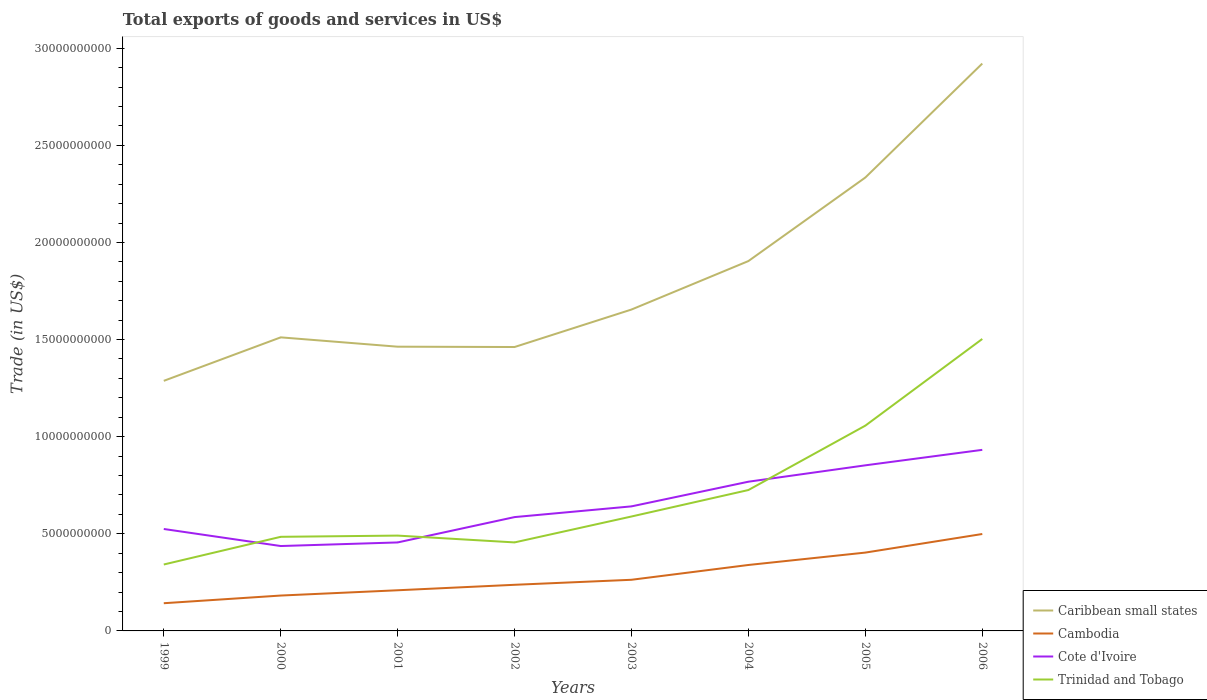How many different coloured lines are there?
Offer a terse response. 4. Across all years, what is the maximum total exports of goods and services in Trinidad and Tobago?
Make the answer very short. 3.42e+09. In which year was the total exports of goods and services in Caribbean small states maximum?
Provide a succinct answer. 1999. What is the total total exports of goods and services in Trinidad and Tobago in the graph?
Give a very brief answer. -1.16e+1. What is the difference between the highest and the second highest total exports of goods and services in Cote d'Ivoire?
Your response must be concise. 4.95e+09. What is the difference between the highest and the lowest total exports of goods and services in Trinidad and Tobago?
Keep it short and to the point. 3. How many lines are there?
Your answer should be very brief. 4. Does the graph contain any zero values?
Make the answer very short. No. Does the graph contain grids?
Ensure brevity in your answer.  No. Where does the legend appear in the graph?
Offer a very short reply. Bottom right. How many legend labels are there?
Provide a short and direct response. 4. What is the title of the graph?
Give a very brief answer. Total exports of goods and services in US$. What is the label or title of the Y-axis?
Your response must be concise. Trade (in US$). What is the Trade (in US$) of Caribbean small states in 1999?
Provide a short and direct response. 1.29e+1. What is the Trade (in US$) in Cambodia in 1999?
Your answer should be very brief. 1.43e+09. What is the Trade (in US$) in Cote d'Ivoire in 1999?
Your answer should be very brief. 5.25e+09. What is the Trade (in US$) of Trinidad and Tobago in 1999?
Your answer should be compact. 3.42e+09. What is the Trade (in US$) of Caribbean small states in 2000?
Your answer should be very brief. 1.51e+1. What is the Trade (in US$) of Cambodia in 2000?
Provide a succinct answer. 1.82e+09. What is the Trade (in US$) of Cote d'Ivoire in 2000?
Provide a short and direct response. 4.37e+09. What is the Trade (in US$) in Trinidad and Tobago in 2000?
Your answer should be very brief. 4.84e+09. What is the Trade (in US$) in Caribbean small states in 2001?
Your answer should be compact. 1.46e+1. What is the Trade (in US$) in Cambodia in 2001?
Keep it short and to the point. 2.09e+09. What is the Trade (in US$) of Cote d'Ivoire in 2001?
Ensure brevity in your answer.  4.56e+09. What is the Trade (in US$) of Trinidad and Tobago in 2001?
Ensure brevity in your answer.  4.91e+09. What is the Trade (in US$) of Caribbean small states in 2002?
Give a very brief answer. 1.46e+1. What is the Trade (in US$) of Cambodia in 2002?
Make the answer very short. 2.37e+09. What is the Trade (in US$) in Cote d'Ivoire in 2002?
Your answer should be compact. 5.86e+09. What is the Trade (in US$) in Trinidad and Tobago in 2002?
Give a very brief answer. 4.56e+09. What is the Trade (in US$) of Caribbean small states in 2003?
Provide a short and direct response. 1.65e+1. What is the Trade (in US$) of Cambodia in 2003?
Your answer should be compact. 2.63e+09. What is the Trade (in US$) in Cote d'Ivoire in 2003?
Make the answer very short. 6.41e+09. What is the Trade (in US$) of Trinidad and Tobago in 2003?
Provide a short and direct response. 5.89e+09. What is the Trade (in US$) of Caribbean small states in 2004?
Your response must be concise. 1.90e+1. What is the Trade (in US$) of Cambodia in 2004?
Your response must be concise. 3.40e+09. What is the Trade (in US$) in Cote d'Ivoire in 2004?
Provide a short and direct response. 7.68e+09. What is the Trade (in US$) in Trinidad and Tobago in 2004?
Your answer should be compact. 7.25e+09. What is the Trade (in US$) of Caribbean small states in 2005?
Provide a short and direct response. 2.33e+1. What is the Trade (in US$) of Cambodia in 2005?
Give a very brief answer. 4.03e+09. What is the Trade (in US$) in Cote d'Ivoire in 2005?
Ensure brevity in your answer.  8.53e+09. What is the Trade (in US$) of Trinidad and Tobago in 2005?
Give a very brief answer. 1.06e+1. What is the Trade (in US$) of Caribbean small states in 2006?
Give a very brief answer. 2.92e+1. What is the Trade (in US$) in Cambodia in 2006?
Provide a succinct answer. 4.99e+09. What is the Trade (in US$) of Cote d'Ivoire in 2006?
Make the answer very short. 9.32e+09. What is the Trade (in US$) of Trinidad and Tobago in 2006?
Provide a succinct answer. 1.50e+1. Across all years, what is the maximum Trade (in US$) in Caribbean small states?
Your response must be concise. 2.92e+1. Across all years, what is the maximum Trade (in US$) of Cambodia?
Your answer should be very brief. 4.99e+09. Across all years, what is the maximum Trade (in US$) of Cote d'Ivoire?
Give a very brief answer. 9.32e+09. Across all years, what is the maximum Trade (in US$) in Trinidad and Tobago?
Keep it short and to the point. 1.50e+1. Across all years, what is the minimum Trade (in US$) in Caribbean small states?
Your answer should be compact. 1.29e+1. Across all years, what is the minimum Trade (in US$) in Cambodia?
Make the answer very short. 1.43e+09. Across all years, what is the minimum Trade (in US$) in Cote d'Ivoire?
Offer a terse response. 4.37e+09. Across all years, what is the minimum Trade (in US$) of Trinidad and Tobago?
Make the answer very short. 3.42e+09. What is the total Trade (in US$) of Caribbean small states in the graph?
Your answer should be very brief. 1.45e+11. What is the total Trade (in US$) of Cambodia in the graph?
Give a very brief answer. 2.28e+1. What is the total Trade (in US$) in Cote d'Ivoire in the graph?
Make the answer very short. 5.20e+1. What is the total Trade (in US$) in Trinidad and Tobago in the graph?
Your answer should be compact. 5.65e+1. What is the difference between the Trade (in US$) of Caribbean small states in 1999 and that in 2000?
Provide a succinct answer. -2.24e+09. What is the difference between the Trade (in US$) of Cambodia in 1999 and that in 2000?
Provide a succinct answer. -3.95e+08. What is the difference between the Trade (in US$) of Cote d'Ivoire in 1999 and that in 2000?
Your response must be concise. 8.77e+08. What is the difference between the Trade (in US$) of Trinidad and Tobago in 1999 and that in 2000?
Provide a short and direct response. -1.43e+09. What is the difference between the Trade (in US$) of Caribbean small states in 1999 and that in 2001?
Offer a terse response. -1.76e+09. What is the difference between the Trade (in US$) of Cambodia in 1999 and that in 2001?
Your answer should be very brief. -6.67e+08. What is the difference between the Trade (in US$) of Cote d'Ivoire in 1999 and that in 2001?
Give a very brief answer. 6.93e+08. What is the difference between the Trade (in US$) of Trinidad and Tobago in 1999 and that in 2001?
Give a very brief answer. -1.49e+09. What is the difference between the Trade (in US$) of Caribbean small states in 1999 and that in 2002?
Keep it short and to the point. -1.74e+09. What is the difference between the Trade (in US$) of Cambodia in 1999 and that in 2002?
Offer a terse response. -9.48e+08. What is the difference between the Trade (in US$) in Cote d'Ivoire in 1999 and that in 2002?
Give a very brief answer. -6.12e+08. What is the difference between the Trade (in US$) of Trinidad and Tobago in 1999 and that in 2002?
Provide a short and direct response. -1.14e+09. What is the difference between the Trade (in US$) of Caribbean small states in 1999 and that in 2003?
Provide a succinct answer. -3.67e+09. What is the difference between the Trade (in US$) in Cambodia in 1999 and that in 2003?
Your response must be concise. -1.21e+09. What is the difference between the Trade (in US$) of Cote d'Ivoire in 1999 and that in 2003?
Your response must be concise. -1.16e+09. What is the difference between the Trade (in US$) of Trinidad and Tobago in 1999 and that in 2003?
Provide a short and direct response. -2.47e+09. What is the difference between the Trade (in US$) of Caribbean small states in 1999 and that in 2004?
Offer a very short reply. -6.17e+09. What is the difference between the Trade (in US$) in Cambodia in 1999 and that in 2004?
Offer a very short reply. -1.97e+09. What is the difference between the Trade (in US$) of Cote d'Ivoire in 1999 and that in 2004?
Offer a very short reply. -2.43e+09. What is the difference between the Trade (in US$) of Trinidad and Tobago in 1999 and that in 2004?
Keep it short and to the point. -3.83e+09. What is the difference between the Trade (in US$) of Caribbean small states in 1999 and that in 2005?
Offer a very short reply. -1.05e+1. What is the difference between the Trade (in US$) in Cambodia in 1999 and that in 2005?
Make the answer very short. -2.61e+09. What is the difference between the Trade (in US$) in Cote d'Ivoire in 1999 and that in 2005?
Ensure brevity in your answer.  -3.28e+09. What is the difference between the Trade (in US$) of Trinidad and Tobago in 1999 and that in 2005?
Your response must be concise. -7.15e+09. What is the difference between the Trade (in US$) of Caribbean small states in 1999 and that in 2006?
Ensure brevity in your answer.  -1.63e+1. What is the difference between the Trade (in US$) of Cambodia in 1999 and that in 2006?
Offer a very short reply. -3.56e+09. What is the difference between the Trade (in US$) of Cote d'Ivoire in 1999 and that in 2006?
Keep it short and to the point. -4.07e+09. What is the difference between the Trade (in US$) in Trinidad and Tobago in 1999 and that in 2006?
Provide a short and direct response. -1.16e+1. What is the difference between the Trade (in US$) of Caribbean small states in 2000 and that in 2001?
Give a very brief answer. 4.81e+08. What is the difference between the Trade (in US$) in Cambodia in 2000 and that in 2001?
Your answer should be very brief. -2.72e+08. What is the difference between the Trade (in US$) of Cote d'Ivoire in 2000 and that in 2001?
Keep it short and to the point. -1.85e+08. What is the difference between the Trade (in US$) of Trinidad and Tobago in 2000 and that in 2001?
Offer a terse response. -6.28e+07. What is the difference between the Trade (in US$) in Caribbean small states in 2000 and that in 2002?
Offer a very short reply. 4.97e+08. What is the difference between the Trade (in US$) in Cambodia in 2000 and that in 2002?
Provide a short and direct response. -5.53e+08. What is the difference between the Trade (in US$) in Cote d'Ivoire in 2000 and that in 2002?
Ensure brevity in your answer.  -1.49e+09. What is the difference between the Trade (in US$) of Trinidad and Tobago in 2000 and that in 2002?
Offer a very short reply. 2.88e+08. What is the difference between the Trade (in US$) in Caribbean small states in 2000 and that in 2003?
Your answer should be compact. -1.43e+09. What is the difference between the Trade (in US$) in Cambodia in 2000 and that in 2003?
Ensure brevity in your answer.  -8.11e+08. What is the difference between the Trade (in US$) of Cote d'Ivoire in 2000 and that in 2003?
Offer a very short reply. -2.04e+09. What is the difference between the Trade (in US$) of Trinidad and Tobago in 2000 and that in 2003?
Give a very brief answer. -1.05e+09. What is the difference between the Trade (in US$) in Caribbean small states in 2000 and that in 2004?
Your answer should be compact. -3.93e+09. What is the difference between the Trade (in US$) of Cambodia in 2000 and that in 2004?
Your response must be concise. -1.57e+09. What is the difference between the Trade (in US$) of Cote d'Ivoire in 2000 and that in 2004?
Provide a succinct answer. -3.31e+09. What is the difference between the Trade (in US$) of Trinidad and Tobago in 2000 and that in 2004?
Offer a very short reply. -2.41e+09. What is the difference between the Trade (in US$) in Caribbean small states in 2000 and that in 2005?
Make the answer very short. -8.23e+09. What is the difference between the Trade (in US$) in Cambodia in 2000 and that in 2005?
Your response must be concise. -2.21e+09. What is the difference between the Trade (in US$) in Cote d'Ivoire in 2000 and that in 2005?
Provide a succinct answer. -4.15e+09. What is the difference between the Trade (in US$) of Trinidad and Tobago in 2000 and that in 2005?
Your answer should be compact. -5.72e+09. What is the difference between the Trade (in US$) of Caribbean small states in 2000 and that in 2006?
Keep it short and to the point. -1.41e+1. What is the difference between the Trade (in US$) in Cambodia in 2000 and that in 2006?
Keep it short and to the point. -3.17e+09. What is the difference between the Trade (in US$) in Cote d'Ivoire in 2000 and that in 2006?
Provide a succinct answer. -4.95e+09. What is the difference between the Trade (in US$) of Trinidad and Tobago in 2000 and that in 2006?
Offer a very short reply. -1.02e+1. What is the difference between the Trade (in US$) of Caribbean small states in 2001 and that in 2002?
Keep it short and to the point. 1.66e+07. What is the difference between the Trade (in US$) of Cambodia in 2001 and that in 2002?
Provide a succinct answer. -2.81e+08. What is the difference between the Trade (in US$) in Cote d'Ivoire in 2001 and that in 2002?
Your response must be concise. -1.30e+09. What is the difference between the Trade (in US$) in Trinidad and Tobago in 2001 and that in 2002?
Make the answer very short. 3.51e+08. What is the difference between the Trade (in US$) in Caribbean small states in 2001 and that in 2003?
Offer a terse response. -1.91e+09. What is the difference between the Trade (in US$) of Cambodia in 2001 and that in 2003?
Offer a very short reply. -5.40e+08. What is the difference between the Trade (in US$) in Cote d'Ivoire in 2001 and that in 2003?
Keep it short and to the point. -1.86e+09. What is the difference between the Trade (in US$) in Trinidad and Tobago in 2001 and that in 2003?
Give a very brief answer. -9.84e+08. What is the difference between the Trade (in US$) in Caribbean small states in 2001 and that in 2004?
Make the answer very short. -4.41e+09. What is the difference between the Trade (in US$) in Cambodia in 2001 and that in 2004?
Your response must be concise. -1.30e+09. What is the difference between the Trade (in US$) of Cote d'Ivoire in 2001 and that in 2004?
Your answer should be compact. -3.13e+09. What is the difference between the Trade (in US$) in Trinidad and Tobago in 2001 and that in 2004?
Provide a short and direct response. -2.35e+09. What is the difference between the Trade (in US$) in Caribbean small states in 2001 and that in 2005?
Your answer should be very brief. -8.71e+09. What is the difference between the Trade (in US$) in Cambodia in 2001 and that in 2005?
Ensure brevity in your answer.  -1.94e+09. What is the difference between the Trade (in US$) of Cote d'Ivoire in 2001 and that in 2005?
Your response must be concise. -3.97e+09. What is the difference between the Trade (in US$) of Trinidad and Tobago in 2001 and that in 2005?
Offer a terse response. -5.66e+09. What is the difference between the Trade (in US$) of Caribbean small states in 2001 and that in 2006?
Provide a succinct answer. -1.46e+1. What is the difference between the Trade (in US$) of Cambodia in 2001 and that in 2006?
Provide a short and direct response. -2.90e+09. What is the difference between the Trade (in US$) in Cote d'Ivoire in 2001 and that in 2006?
Offer a very short reply. -4.77e+09. What is the difference between the Trade (in US$) of Trinidad and Tobago in 2001 and that in 2006?
Offer a very short reply. -1.01e+1. What is the difference between the Trade (in US$) in Caribbean small states in 2002 and that in 2003?
Ensure brevity in your answer.  -1.93e+09. What is the difference between the Trade (in US$) in Cambodia in 2002 and that in 2003?
Your answer should be compact. -2.59e+08. What is the difference between the Trade (in US$) in Cote d'Ivoire in 2002 and that in 2003?
Your response must be concise. -5.52e+08. What is the difference between the Trade (in US$) in Trinidad and Tobago in 2002 and that in 2003?
Keep it short and to the point. -1.33e+09. What is the difference between the Trade (in US$) in Caribbean small states in 2002 and that in 2004?
Provide a short and direct response. -4.43e+09. What is the difference between the Trade (in US$) in Cambodia in 2002 and that in 2004?
Make the answer very short. -1.02e+09. What is the difference between the Trade (in US$) of Cote d'Ivoire in 2002 and that in 2004?
Provide a short and direct response. -1.82e+09. What is the difference between the Trade (in US$) of Trinidad and Tobago in 2002 and that in 2004?
Your answer should be very brief. -2.70e+09. What is the difference between the Trade (in US$) in Caribbean small states in 2002 and that in 2005?
Keep it short and to the point. -8.73e+09. What is the difference between the Trade (in US$) in Cambodia in 2002 and that in 2005?
Ensure brevity in your answer.  -1.66e+09. What is the difference between the Trade (in US$) of Cote d'Ivoire in 2002 and that in 2005?
Ensure brevity in your answer.  -2.66e+09. What is the difference between the Trade (in US$) in Trinidad and Tobago in 2002 and that in 2005?
Keep it short and to the point. -6.01e+09. What is the difference between the Trade (in US$) of Caribbean small states in 2002 and that in 2006?
Ensure brevity in your answer.  -1.46e+1. What is the difference between the Trade (in US$) of Cambodia in 2002 and that in 2006?
Provide a short and direct response. -2.62e+09. What is the difference between the Trade (in US$) of Cote d'Ivoire in 2002 and that in 2006?
Your answer should be very brief. -3.46e+09. What is the difference between the Trade (in US$) in Trinidad and Tobago in 2002 and that in 2006?
Ensure brevity in your answer.  -1.05e+1. What is the difference between the Trade (in US$) in Caribbean small states in 2003 and that in 2004?
Offer a very short reply. -2.50e+09. What is the difference between the Trade (in US$) in Cambodia in 2003 and that in 2004?
Offer a terse response. -7.62e+08. What is the difference between the Trade (in US$) of Cote d'Ivoire in 2003 and that in 2004?
Give a very brief answer. -1.27e+09. What is the difference between the Trade (in US$) of Trinidad and Tobago in 2003 and that in 2004?
Offer a terse response. -1.36e+09. What is the difference between the Trade (in US$) in Caribbean small states in 2003 and that in 2005?
Provide a succinct answer. -6.80e+09. What is the difference between the Trade (in US$) of Cambodia in 2003 and that in 2005?
Give a very brief answer. -1.40e+09. What is the difference between the Trade (in US$) in Cote d'Ivoire in 2003 and that in 2005?
Keep it short and to the point. -2.11e+09. What is the difference between the Trade (in US$) in Trinidad and Tobago in 2003 and that in 2005?
Make the answer very short. -4.68e+09. What is the difference between the Trade (in US$) in Caribbean small states in 2003 and that in 2006?
Your response must be concise. -1.27e+1. What is the difference between the Trade (in US$) in Cambodia in 2003 and that in 2006?
Provide a short and direct response. -2.36e+09. What is the difference between the Trade (in US$) in Cote d'Ivoire in 2003 and that in 2006?
Keep it short and to the point. -2.91e+09. What is the difference between the Trade (in US$) in Trinidad and Tobago in 2003 and that in 2006?
Give a very brief answer. -9.14e+09. What is the difference between the Trade (in US$) in Caribbean small states in 2004 and that in 2005?
Your answer should be very brief. -4.30e+09. What is the difference between the Trade (in US$) in Cambodia in 2004 and that in 2005?
Your response must be concise. -6.38e+08. What is the difference between the Trade (in US$) in Cote d'Ivoire in 2004 and that in 2005?
Offer a terse response. -8.43e+08. What is the difference between the Trade (in US$) in Trinidad and Tobago in 2004 and that in 2005?
Offer a terse response. -3.31e+09. What is the difference between the Trade (in US$) in Caribbean small states in 2004 and that in 2006?
Provide a succinct answer. -1.02e+1. What is the difference between the Trade (in US$) in Cambodia in 2004 and that in 2006?
Your answer should be compact. -1.59e+09. What is the difference between the Trade (in US$) in Cote d'Ivoire in 2004 and that in 2006?
Provide a short and direct response. -1.64e+09. What is the difference between the Trade (in US$) in Trinidad and Tobago in 2004 and that in 2006?
Your answer should be very brief. -7.78e+09. What is the difference between the Trade (in US$) of Caribbean small states in 2005 and that in 2006?
Keep it short and to the point. -5.87e+09. What is the difference between the Trade (in US$) of Cambodia in 2005 and that in 2006?
Your response must be concise. -9.57e+08. What is the difference between the Trade (in US$) of Cote d'Ivoire in 2005 and that in 2006?
Provide a short and direct response. -7.97e+08. What is the difference between the Trade (in US$) in Trinidad and Tobago in 2005 and that in 2006?
Offer a very short reply. -4.46e+09. What is the difference between the Trade (in US$) in Caribbean small states in 1999 and the Trade (in US$) in Cambodia in 2000?
Offer a very short reply. 1.11e+1. What is the difference between the Trade (in US$) of Caribbean small states in 1999 and the Trade (in US$) of Cote d'Ivoire in 2000?
Make the answer very short. 8.50e+09. What is the difference between the Trade (in US$) of Caribbean small states in 1999 and the Trade (in US$) of Trinidad and Tobago in 2000?
Offer a very short reply. 8.03e+09. What is the difference between the Trade (in US$) in Cambodia in 1999 and the Trade (in US$) in Cote d'Ivoire in 2000?
Make the answer very short. -2.94e+09. What is the difference between the Trade (in US$) in Cambodia in 1999 and the Trade (in US$) in Trinidad and Tobago in 2000?
Your answer should be very brief. -3.42e+09. What is the difference between the Trade (in US$) of Cote d'Ivoire in 1999 and the Trade (in US$) of Trinidad and Tobago in 2000?
Offer a terse response. 4.03e+08. What is the difference between the Trade (in US$) of Caribbean small states in 1999 and the Trade (in US$) of Cambodia in 2001?
Ensure brevity in your answer.  1.08e+1. What is the difference between the Trade (in US$) of Caribbean small states in 1999 and the Trade (in US$) of Cote d'Ivoire in 2001?
Offer a very short reply. 8.32e+09. What is the difference between the Trade (in US$) of Caribbean small states in 1999 and the Trade (in US$) of Trinidad and Tobago in 2001?
Ensure brevity in your answer.  7.97e+09. What is the difference between the Trade (in US$) in Cambodia in 1999 and the Trade (in US$) in Cote d'Ivoire in 2001?
Your answer should be compact. -3.13e+09. What is the difference between the Trade (in US$) in Cambodia in 1999 and the Trade (in US$) in Trinidad and Tobago in 2001?
Make the answer very short. -3.48e+09. What is the difference between the Trade (in US$) in Cote d'Ivoire in 1999 and the Trade (in US$) in Trinidad and Tobago in 2001?
Offer a terse response. 3.40e+08. What is the difference between the Trade (in US$) of Caribbean small states in 1999 and the Trade (in US$) of Cambodia in 2002?
Your answer should be compact. 1.05e+1. What is the difference between the Trade (in US$) of Caribbean small states in 1999 and the Trade (in US$) of Cote d'Ivoire in 2002?
Offer a terse response. 7.01e+09. What is the difference between the Trade (in US$) of Caribbean small states in 1999 and the Trade (in US$) of Trinidad and Tobago in 2002?
Your answer should be compact. 8.32e+09. What is the difference between the Trade (in US$) in Cambodia in 1999 and the Trade (in US$) in Cote d'Ivoire in 2002?
Your response must be concise. -4.43e+09. What is the difference between the Trade (in US$) of Cambodia in 1999 and the Trade (in US$) of Trinidad and Tobago in 2002?
Give a very brief answer. -3.13e+09. What is the difference between the Trade (in US$) in Cote d'Ivoire in 1999 and the Trade (in US$) in Trinidad and Tobago in 2002?
Give a very brief answer. 6.91e+08. What is the difference between the Trade (in US$) of Caribbean small states in 1999 and the Trade (in US$) of Cambodia in 2003?
Offer a terse response. 1.02e+1. What is the difference between the Trade (in US$) of Caribbean small states in 1999 and the Trade (in US$) of Cote d'Ivoire in 2003?
Make the answer very short. 6.46e+09. What is the difference between the Trade (in US$) of Caribbean small states in 1999 and the Trade (in US$) of Trinidad and Tobago in 2003?
Offer a very short reply. 6.98e+09. What is the difference between the Trade (in US$) of Cambodia in 1999 and the Trade (in US$) of Cote d'Ivoire in 2003?
Provide a succinct answer. -4.99e+09. What is the difference between the Trade (in US$) of Cambodia in 1999 and the Trade (in US$) of Trinidad and Tobago in 2003?
Make the answer very short. -4.47e+09. What is the difference between the Trade (in US$) of Cote d'Ivoire in 1999 and the Trade (in US$) of Trinidad and Tobago in 2003?
Your response must be concise. -6.43e+08. What is the difference between the Trade (in US$) in Caribbean small states in 1999 and the Trade (in US$) in Cambodia in 2004?
Ensure brevity in your answer.  9.48e+09. What is the difference between the Trade (in US$) in Caribbean small states in 1999 and the Trade (in US$) in Cote d'Ivoire in 2004?
Ensure brevity in your answer.  5.19e+09. What is the difference between the Trade (in US$) of Caribbean small states in 1999 and the Trade (in US$) of Trinidad and Tobago in 2004?
Give a very brief answer. 5.62e+09. What is the difference between the Trade (in US$) of Cambodia in 1999 and the Trade (in US$) of Cote d'Ivoire in 2004?
Provide a short and direct response. -6.26e+09. What is the difference between the Trade (in US$) in Cambodia in 1999 and the Trade (in US$) in Trinidad and Tobago in 2004?
Provide a short and direct response. -5.83e+09. What is the difference between the Trade (in US$) of Cote d'Ivoire in 1999 and the Trade (in US$) of Trinidad and Tobago in 2004?
Give a very brief answer. -2.01e+09. What is the difference between the Trade (in US$) in Caribbean small states in 1999 and the Trade (in US$) in Cambodia in 2005?
Keep it short and to the point. 8.84e+09. What is the difference between the Trade (in US$) of Caribbean small states in 1999 and the Trade (in US$) of Cote d'Ivoire in 2005?
Make the answer very short. 4.35e+09. What is the difference between the Trade (in US$) in Caribbean small states in 1999 and the Trade (in US$) in Trinidad and Tobago in 2005?
Give a very brief answer. 2.31e+09. What is the difference between the Trade (in US$) of Cambodia in 1999 and the Trade (in US$) of Cote d'Ivoire in 2005?
Make the answer very short. -7.10e+09. What is the difference between the Trade (in US$) in Cambodia in 1999 and the Trade (in US$) in Trinidad and Tobago in 2005?
Make the answer very short. -9.14e+09. What is the difference between the Trade (in US$) in Cote d'Ivoire in 1999 and the Trade (in US$) in Trinidad and Tobago in 2005?
Make the answer very short. -5.32e+09. What is the difference between the Trade (in US$) in Caribbean small states in 1999 and the Trade (in US$) in Cambodia in 2006?
Make the answer very short. 7.88e+09. What is the difference between the Trade (in US$) of Caribbean small states in 1999 and the Trade (in US$) of Cote d'Ivoire in 2006?
Offer a very short reply. 3.55e+09. What is the difference between the Trade (in US$) in Caribbean small states in 1999 and the Trade (in US$) in Trinidad and Tobago in 2006?
Provide a short and direct response. -2.16e+09. What is the difference between the Trade (in US$) in Cambodia in 1999 and the Trade (in US$) in Cote d'Ivoire in 2006?
Provide a succinct answer. -7.90e+09. What is the difference between the Trade (in US$) of Cambodia in 1999 and the Trade (in US$) of Trinidad and Tobago in 2006?
Make the answer very short. -1.36e+1. What is the difference between the Trade (in US$) of Cote d'Ivoire in 1999 and the Trade (in US$) of Trinidad and Tobago in 2006?
Your answer should be compact. -9.78e+09. What is the difference between the Trade (in US$) of Caribbean small states in 2000 and the Trade (in US$) of Cambodia in 2001?
Make the answer very short. 1.30e+1. What is the difference between the Trade (in US$) of Caribbean small states in 2000 and the Trade (in US$) of Cote d'Ivoire in 2001?
Offer a terse response. 1.06e+1. What is the difference between the Trade (in US$) in Caribbean small states in 2000 and the Trade (in US$) in Trinidad and Tobago in 2001?
Keep it short and to the point. 1.02e+1. What is the difference between the Trade (in US$) in Cambodia in 2000 and the Trade (in US$) in Cote d'Ivoire in 2001?
Make the answer very short. -2.73e+09. What is the difference between the Trade (in US$) of Cambodia in 2000 and the Trade (in US$) of Trinidad and Tobago in 2001?
Your answer should be compact. -3.09e+09. What is the difference between the Trade (in US$) of Cote d'Ivoire in 2000 and the Trade (in US$) of Trinidad and Tobago in 2001?
Make the answer very short. -5.37e+08. What is the difference between the Trade (in US$) in Caribbean small states in 2000 and the Trade (in US$) in Cambodia in 2002?
Offer a terse response. 1.27e+1. What is the difference between the Trade (in US$) in Caribbean small states in 2000 and the Trade (in US$) in Cote d'Ivoire in 2002?
Provide a short and direct response. 9.25e+09. What is the difference between the Trade (in US$) in Caribbean small states in 2000 and the Trade (in US$) in Trinidad and Tobago in 2002?
Keep it short and to the point. 1.06e+1. What is the difference between the Trade (in US$) of Cambodia in 2000 and the Trade (in US$) of Cote d'Ivoire in 2002?
Provide a succinct answer. -4.04e+09. What is the difference between the Trade (in US$) in Cambodia in 2000 and the Trade (in US$) in Trinidad and Tobago in 2002?
Offer a very short reply. -2.74e+09. What is the difference between the Trade (in US$) of Cote d'Ivoire in 2000 and the Trade (in US$) of Trinidad and Tobago in 2002?
Offer a terse response. -1.86e+08. What is the difference between the Trade (in US$) of Caribbean small states in 2000 and the Trade (in US$) of Cambodia in 2003?
Make the answer very short. 1.25e+1. What is the difference between the Trade (in US$) in Caribbean small states in 2000 and the Trade (in US$) in Cote d'Ivoire in 2003?
Offer a very short reply. 8.70e+09. What is the difference between the Trade (in US$) of Caribbean small states in 2000 and the Trade (in US$) of Trinidad and Tobago in 2003?
Offer a terse response. 9.22e+09. What is the difference between the Trade (in US$) in Cambodia in 2000 and the Trade (in US$) in Cote d'Ivoire in 2003?
Give a very brief answer. -4.59e+09. What is the difference between the Trade (in US$) of Cambodia in 2000 and the Trade (in US$) of Trinidad and Tobago in 2003?
Ensure brevity in your answer.  -4.07e+09. What is the difference between the Trade (in US$) in Cote d'Ivoire in 2000 and the Trade (in US$) in Trinidad and Tobago in 2003?
Make the answer very short. -1.52e+09. What is the difference between the Trade (in US$) of Caribbean small states in 2000 and the Trade (in US$) of Cambodia in 2004?
Your answer should be very brief. 1.17e+1. What is the difference between the Trade (in US$) of Caribbean small states in 2000 and the Trade (in US$) of Cote d'Ivoire in 2004?
Your answer should be compact. 7.43e+09. What is the difference between the Trade (in US$) of Caribbean small states in 2000 and the Trade (in US$) of Trinidad and Tobago in 2004?
Give a very brief answer. 7.86e+09. What is the difference between the Trade (in US$) in Cambodia in 2000 and the Trade (in US$) in Cote d'Ivoire in 2004?
Your response must be concise. -5.86e+09. What is the difference between the Trade (in US$) of Cambodia in 2000 and the Trade (in US$) of Trinidad and Tobago in 2004?
Offer a very short reply. -5.43e+09. What is the difference between the Trade (in US$) of Cote d'Ivoire in 2000 and the Trade (in US$) of Trinidad and Tobago in 2004?
Your response must be concise. -2.88e+09. What is the difference between the Trade (in US$) in Caribbean small states in 2000 and the Trade (in US$) in Cambodia in 2005?
Your answer should be compact. 1.11e+1. What is the difference between the Trade (in US$) in Caribbean small states in 2000 and the Trade (in US$) in Cote d'Ivoire in 2005?
Your answer should be compact. 6.59e+09. What is the difference between the Trade (in US$) in Caribbean small states in 2000 and the Trade (in US$) in Trinidad and Tobago in 2005?
Your answer should be compact. 4.54e+09. What is the difference between the Trade (in US$) in Cambodia in 2000 and the Trade (in US$) in Cote d'Ivoire in 2005?
Provide a succinct answer. -6.70e+09. What is the difference between the Trade (in US$) in Cambodia in 2000 and the Trade (in US$) in Trinidad and Tobago in 2005?
Ensure brevity in your answer.  -8.75e+09. What is the difference between the Trade (in US$) in Cote d'Ivoire in 2000 and the Trade (in US$) in Trinidad and Tobago in 2005?
Make the answer very short. -6.20e+09. What is the difference between the Trade (in US$) in Caribbean small states in 2000 and the Trade (in US$) in Cambodia in 2006?
Offer a terse response. 1.01e+1. What is the difference between the Trade (in US$) in Caribbean small states in 2000 and the Trade (in US$) in Cote d'Ivoire in 2006?
Your response must be concise. 5.79e+09. What is the difference between the Trade (in US$) of Caribbean small states in 2000 and the Trade (in US$) of Trinidad and Tobago in 2006?
Make the answer very short. 8.29e+07. What is the difference between the Trade (in US$) in Cambodia in 2000 and the Trade (in US$) in Cote d'Ivoire in 2006?
Provide a short and direct response. -7.50e+09. What is the difference between the Trade (in US$) of Cambodia in 2000 and the Trade (in US$) of Trinidad and Tobago in 2006?
Keep it short and to the point. -1.32e+1. What is the difference between the Trade (in US$) in Cote d'Ivoire in 2000 and the Trade (in US$) in Trinidad and Tobago in 2006?
Offer a terse response. -1.07e+1. What is the difference between the Trade (in US$) of Caribbean small states in 2001 and the Trade (in US$) of Cambodia in 2002?
Your answer should be compact. 1.23e+1. What is the difference between the Trade (in US$) of Caribbean small states in 2001 and the Trade (in US$) of Cote d'Ivoire in 2002?
Keep it short and to the point. 8.77e+09. What is the difference between the Trade (in US$) of Caribbean small states in 2001 and the Trade (in US$) of Trinidad and Tobago in 2002?
Your answer should be compact. 1.01e+1. What is the difference between the Trade (in US$) in Cambodia in 2001 and the Trade (in US$) in Cote d'Ivoire in 2002?
Your answer should be very brief. -3.77e+09. What is the difference between the Trade (in US$) in Cambodia in 2001 and the Trade (in US$) in Trinidad and Tobago in 2002?
Your answer should be very brief. -2.46e+09. What is the difference between the Trade (in US$) of Cote d'Ivoire in 2001 and the Trade (in US$) of Trinidad and Tobago in 2002?
Your answer should be very brief. -1.57e+06. What is the difference between the Trade (in US$) in Caribbean small states in 2001 and the Trade (in US$) in Cambodia in 2003?
Your response must be concise. 1.20e+1. What is the difference between the Trade (in US$) of Caribbean small states in 2001 and the Trade (in US$) of Cote d'Ivoire in 2003?
Keep it short and to the point. 8.22e+09. What is the difference between the Trade (in US$) in Caribbean small states in 2001 and the Trade (in US$) in Trinidad and Tobago in 2003?
Provide a succinct answer. 8.74e+09. What is the difference between the Trade (in US$) of Cambodia in 2001 and the Trade (in US$) of Cote d'Ivoire in 2003?
Provide a succinct answer. -4.32e+09. What is the difference between the Trade (in US$) of Cambodia in 2001 and the Trade (in US$) of Trinidad and Tobago in 2003?
Ensure brevity in your answer.  -3.80e+09. What is the difference between the Trade (in US$) in Cote d'Ivoire in 2001 and the Trade (in US$) in Trinidad and Tobago in 2003?
Keep it short and to the point. -1.34e+09. What is the difference between the Trade (in US$) of Caribbean small states in 2001 and the Trade (in US$) of Cambodia in 2004?
Provide a short and direct response. 1.12e+1. What is the difference between the Trade (in US$) of Caribbean small states in 2001 and the Trade (in US$) of Cote d'Ivoire in 2004?
Your answer should be very brief. 6.95e+09. What is the difference between the Trade (in US$) of Caribbean small states in 2001 and the Trade (in US$) of Trinidad and Tobago in 2004?
Provide a succinct answer. 7.38e+09. What is the difference between the Trade (in US$) in Cambodia in 2001 and the Trade (in US$) in Cote d'Ivoire in 2004?
Ensure brevity in your answer.  -5.59e+09. What is the difference between the Trade (in US$) of Cambodia in 2001 and the Trade (in US$) of Trinidad and Tobago in 2004?
Offer a very short reply. -5.16e+09. What is the difference between the Trade (in US$) in Cote d'Ivoire in 2001 and the Trade (in US$) in Trinidad and Tobago in 2004?
Ensure brevity in your answer.  -2.70e+09. What is the difference between the Trade (in US$) of Caribbean small states in 2001 and the Trade (in US$) of Cambodia in 2005?
Offer a terse response. 1.06e+1. What is the difference between the Trade (in US$) in Caribbean small states in 2001 and the Trade (in US$) in Cote d'Ivoire in 2005?
Your answer should be very brief. 6.11e+09. What is the difference between the Trade (in US$) of Caribbean small states in 2001 and the Trade (in US$) of Trinidad and Tobago in 2005?
Make the answer very short. 4.06e+09. What is the difference between the Trade (in US$) of Cambodia in 2001 and the Trade (in US$) of Cote d'Ivoire in 2005?
Your response must be concise. -6.43e+09. What is the difference between the Trade (in US$) in Cambodia in 2001 and the Trade (in US$) in Trinidad and Tobago in 2005?
Your answer should be compact. -8.48e+09. What is the difference between the Trade (in US$) of Cote d'Ivoire in 2001 and the Trade (in US$) of Trinidad and Tobago in 2005?
Ensure brevity in your answer.  -6.01e+09. What is the difference between the Trade (in US$) in Caribbean small states in 2001 and the Trade (in US$) in Cambodia in 2006?
Keep it short and to the point. 9.64e+09. What is the difference between the Trade (in US$) in Caribbean small states in 2001 and the Trade (in US$) in Cote d'Ivoire in 2006?
Your response must be concise. 5.31e+09. What is the difference between the Trade (in US$) in Caribbean small states in 2001 and the Trade (in US$) in Trinidad and Tobago in 2006?
Your answer should be very brief. -3.98e+08. What is the difference between the Trade (in US$) in Cambodia in 2001 and the Trade (in US$) in Cote d'Ivoire in 2006?
Provide a short and direct response. -7.23e+09. What is the difference between the Trade (in US$) of Cambodia in 2001 and the Trade (in US$) of Trinidad and Tobago in 2006?
Provide a succinct answer. -1.29e+1. What is the difference between the Trade (in US$) in Cote d'Ivoire in 2001 and the Trade (in US$) in Trinidad and Tobago in 2006?
Your response must be concise. -1.05e+1. What is the difference between the Trade (in US$) of Caribbean small states in 2002 and the Trade (in US$) of Cambodia in 2003?
Provide a short and direct response. 1.20e+1. What is the difference between the Trade (in US$) in Caribbean small states in 2002 and the Trade (in US$) in Cote d'Ivoire in 2003?
Ensure brevity in your answer.  8.20e+09. What is the difference between the Trade (in US$) of Caribbean small states in 2002 and the Trade (in US$) of Trinidad and Tobago in 2003?
Give a very brief answer. 8.72e+09. What is the difference between the Trade (in US$) of Cambodia in 2002 and the Trade (in US$) of Cote d'Ivoire in 2003?
Your answer should be compact. -4.04e+09. What is the difference between the Trade (in US$) of Cambodia in 2002 and the Trade (in US$) of Trinidad and Tobago in 2003?
Ensure brevity in your answer.  -3.52e+09. What is the difference between the Trade (in US$) in Cote d'Ivoire in 2002 and the Trade (in US$) in Trinidad and Tobago in 2003?
Give a very brief answer. -3.11e+07. What is the difference between the Trade (in US$) of Caribbean small states in 2002 and the Trade (in US$) of Cambodia in 2004?
Ensure brevity in your answer.  1.12e+1. What is the difference between the Trade (in US$) of Caribbean small states in 2002 and the Trade (in US$) of Cote d'Ivoire in 2004?
Offer a terse response. 6.93e+09. What is the difference between the Trade (in US$) of Caribbean small states in 2002 and the Trade (in US$) of Trinidad and Tobago in 2004?
Offer a very short reply. 7.36e+09. What is the difference between the Trade (in US$) in Cambodia in 2002 and the Trade (in US$) in Cote d'Ivoire in 2004?
Offer a very short reply. -5.31e+09. What is the difference between the Trade (in US$) in Cambodia in 2002 and the Trade (in US$) in Trinidad and Tobago in 2004?
Give a very brief answer. -4.88e+09. What is the difference between the Trade (in US$) in Cote d'Ivoire in 2002 and the Trade (in US$) in Trinidad and Tobago in 2004?
Offer a very short reply. -1.39e+09. What is the difference between the Trade (in US$) of Caribbean small states in 2002 and the Trade (in US$) of Cambodia in 2005?
Offer a terse response. 1.06e+1. What is the difference between the Trade (in US$) of Caribbean small states in 2002 and the Trade (in US$) of Cote d'Ivoire in 2005?
Offer a very short reply. 6.09e+09. What is the difference between the Trade (in US$) in Caribbean small states in 2002 and the Trade (in US$) in Trinidad and Tobago in 2005?
Make the answer very short. 4.05e+09. What is the difference between the Trade (in US$) in Cambodia in 2002 and the Trade (in US$) in Cote d'Ivoire in 2005?
Make the answer very short. -6.15e+09. What is the difference between the Trade (in US$) in Cambodia in 2002 and the Trade (in US$) in Trinidad and Tobago in 2005?
Keep it short and to the point. -8.19e+09. What is the difference between the Trade (in US$) of Cote d'Ivoire in 2002 and the Trade (in US$) of Trinidad and Tobago in 2005?
Provide a short and direct response. -4.71e+09. What is the difference between the Trade (in US$) in Caribbean small states in 2002 and the Trade (in US$) in Cambodia in 2006?
Provide a succinct answer. 9.63e+09. What is the difference between the Trade (in US$) in Caribbean small states in 2002 and the Trade (in US$) in Cote d'Ivoire in 2006?
Your answer should be compact. 5.29e+09. What is the difference between the Trade (in US$) in Caribbean small states in 2002 and the Trade (in US$) in Trinidad and Tobago in 2006?
Offer a terse response. -4.15e+08. What is the difference between the Trade (in US$) of Cambodia in 2002 and the Trade (in US$) of Cote d'Ivoire in 2006?
Provide a short and direct response. -6.95e+09. What is the difference between the Trade (in US$) in Cambodia in 2002 and the Trade (in US$) in Trinidad and Tobago in 2006?
Make the answer very short. -1.27e+1. What is the difference between the Trade (in US$) of Cote d'Ivoire in 2002 and the Trade (in US$) of Trinidad and Tobago in 2006?
Your answer should be very brief. -9.17e+09. What is the difference between the Trade (in US$) in Caribbean small states in 2003 and the Trade (in US$) in Cambodia in 2004?
Keep it short and to the point. 1.32e+1. What is the difference between the Trade (in US$) in Caribbean small states in 2003 and the Trade (in US$) in Cote d'Ivoire in 2004?
Keep it short and to the point. 8.86e+09. What is the difference between the Trade (in US$) of Caribbean small states in 2003 and the Trade (in US$) of Trinidad and Tobago in 2004?
Your response must be concise. 9.29e+09. What is the difference between the Trade (in US$) of Cambodia in 2003 and the Trade (in US$) of Cote d'Ivoire in 2004?
Ensure brevity in your answer.  -5.05e+09. What is the difference between the Trade (in US$) in Cambodia in 2003 and the Trade (in US$) in Trinidad and Tobago in 2004?
Your response must be concise. -4.62e+09. What is the difference between the Trade (in US$) of Cote d'Ivoire in 2003 and the Trade (in US$) of Trinidad and Tobago in 2004?
Your answer should be compact. -8.42e+08. What is the difference between the Trade (in US$) in Caribbean small states in 2003 and the Trade (in US$) in Cambodia in 2005?
Your answer should be very brief. 1.25e+1. What is the difference between the Trade (in US$) in Caribbean small states in 2003 and the Trade (in US$) in Cote d'Ivoire in 2005?
Provide a short and direct response. 8.02e+09. What is the difference between the Trade (in US$) in Caribbean small states in 2003 and the Trade (in US$) in Trinidad and Tobago in 2005?
Provide a succinct answer. 5.98e+09. What is the difference between the Trade (in US$) of Cambodia in 2003 and the Trade (in US$) of Cote d'Ivoire in 2005?
Your answer should be compact. -5.89e+09. What is the difference between the Trade (in US$) of Cambodia in 2003 and the Trade (in US$) of Trinidad and Tobago in 2005?
Ensure brevity in your answer.  -7.94e+09. What is the difference between the Trade (in US$) in Cote d'Ivoire in 2003 and the Trade (in US$) in Trinidad and Tobago in 2005?
Make the answer very short. -4.16e+09. What is the difference between the Trade (in US$) of Caribbean small states in 2003 and the Trade (in US$) of Cambodia in 2006?
Your response must be concise. 1.16e+1. What is the difference between the Trade (in US$) of Caribbean small states in 2003 and the Trade (in US$) of Cote d'Ivoire in 2006?
Keep it short and to the point. 7.22e+09. What is the difference between the Trade (in US$) in Caribbean small states in 2003 and the Trade (in US$) in Trinidad and Tobago in 2006?
Offer a terse response. 1.52e+09. What is the difference between the Trade (in US$) of Cambodia in 2003 and the Trade (in US$) of Cote d'Ivoire in 2006?
Ensure brevity in your answer.  -6.69e+09. What is the difference between the Trade (in US$) in Cambodia in 2003 and the Trade (in US$) in Trinidad and Tobago in 2006?
Give a very brief answer. -1.24e+1. What is the difference between the Trade (in US$) of Cote d'Ivoire in 2003 and the Trade (in US$) of Trinidad and Tobago in 2006?
Ensure brevity in your answer.  -8.62e+09. What is the difference between the Trade (in US$) of Caribbean small states in 2004 and the Trade (in US$) of Cambodia in 2005?
Offer a very short reply. 1.50e+1. What is the difference between the Trade (in US$) in Caribbean small states in 2004 and the Trade (in US$) in Cote d'Ivoire in 2005?
Provide a short and direct response. 1.05e+1. What is the difference between the Trade (in US$) in Caribbean small states in 2004 and the Trade (in US$) in Trinidad and Tobago in 2005?
Your answer should be compact. 8.47e+09. What is the difference between the Trade (in US$) in Cambodia in 2004 and the Trade (in US$) in Cote d'Ivoire in 2005?
Provide a short and direct response. -5.13e+09. What is the difference between the Trade (in US$) in Cambodia in 2004 and the Trade (in US$) in Trinidad and Tobago in 2005?
Give a very brief answer. -7.17e+09. What is the difference between the Trade (in US$) of Cote d'Ivoire in 2004 and the Trade (in US$) of Trinidad and Tobago in 2005?
Keep it short and to the point. -2.89e+09. What is the difference between the Trade (in US$) in Caribbean small states in 2004 and the Trade (in US$) in Cambodia in 2006?
Give a very brief answer. 1.41e+1. What is the difference between the Trade (in US$) of Caribbean small states in 2004 and the Trade (in US$) of Cote d'Ivoire in 2006?
Ensure brevity in your answer.  9.72e+09. What is the difference between the Trade (in US$) of Caribbean small states in 2004 and the Trade (in US$) of Trinidad and Tobago in 2006?
Offer a very short reply. 4.01e+09. What is the difference between the Trade (in US$) of Cambodia in 2004 and the Trade (in US$) of Cote d'Ivoire in 2006?
Give a very brief answer. -5.93e+09. What is the difference between the Trade (in US$) in Cambodia in 2004 and the Trade (in US$) in Trinidad and Tobago in 2006?
Your answer should be very brief. -1.16e+1. What is the difference between the Trade (in US$) in Cote d'Ivoire in 2004 and the Trade (in US$) in Trinidad and Tobago in 2006?
Offer a very short reply. -7.35e+09. What is the difference between the Trade (in US$) of Caribbean small states in 2005 and the Trade (in US$) of Cambodia in 2006?
Keep it short and to the point. 1.84e+1. What is the difference between the Trade (in US$) in Caribbean small states in 2005 and the Trade (in US$) in Cote d'Ivoire in 2006?
Provide a short and direct response. 1.40e+1. What is the difference between the Trade (in US$) of Caribbean small states in 2005 and the Trade (in US$) of Trinidad and Tobago in 2006?
Keep it short and to the point. 8.31e+09. What is the difference between the Trade (in US$) of Cambodia in 2005 and the Trade (in US$) of Cote d'Ivoire in 2006?
Provide a short and direct response. -5.29e+09. What is the difference between the Trade (in US$) in Cambodia in 2005 and the Trade (in US$) in Trinidad and Tobago in 2006?
Your answer should be compact. -1.10e+1. What is the difference between the Trade (in US$) of Cote d'Ivoire in 2005 and the Trade (in US$) of Trinidad and Tobago in 2006?
Your response must be concise. -6.51e+09. What is the average Trade (in US$) of Caribbean small states per year?
Offer a terse response. 1.82e+1. What is the average Trade (in US$) of Cambodia per year?
Your response must be concise. 2.85e+09. What is the average Trade (in US$) of Cote d'Ivoire per year?
Your response must be concise. 6.50e+09. What is the average Trade (in US$) of Trinidad and Tobago per year?
Give a very brief answer. 7.06e+09. In the year 1999, what is the difference between the Trade (in US$) in Caribbean small states and Trade (in US$) in Cambodia?
Provide a succinct answer. 1.14e+1. In the year 1999, what is the difference between the Trade (in US$) of Caribbean small states and Trade (in US$) of Cote d'Ivoire?
Your answer should be very brief. 7.63e+09. In the year 1999, what is the difference between the Trade (in US$) in Caribbean small states and Trade (in US$) in Trinidad and Tobago?
Offer a very short reply. 9.45e+09. In the year 1999, what is the difference between the Trade (in US$) of Cambodia and Trade (in US$) of Cote d'Ivoire?
Provide a succinct answer. -3.82e+09. In the year 1999, what is the difference between the Trade (in US$) of Cambodia and Trade (in US$) of Trinidad and Tobago?
Offer a very short reply. -1.99e+09. In the year 1999, what is the difference between the Trade (in US$) in Cote d'Ivoire and Trade (in US$) in Trinidad and Tobago?
Offer a terse response. 1.83e+09. In the year 2000, what is the difference between the Trade (in US$) of Caribbean small states and Trade (in US$) of Cambodia?
Keep it short and to the point. 1.33e+1. In the year 2000, what is the difference between the Trade (in US$) in Caribbean small states and Trade (in US$) in Cote d'Ivoire?
Ensure brevity in your answer.  1.07e+1. In the year 2000, what is the difference between the Trade (in US$) in Caribbean small states and Trade (in US$) in Trinidad and Tobago?
Provide a succinct answer. 1.03e+1. In the year 2000, what is the difference between the Trade (in US$) in Cambodia and Trade (in US$) in Cote d'Ivoire?
Your answer should be compact. -2.55e+09. In the year 2000, what is the difference between the Trade (in US$) of Cambodia and Trade (in US$) of Trinidad and Tobago?
Offer a very short reply. -3.02e+09. In the year 2000, what is the difference between the Trade (in US$) of Cote d'Ivoire and Trade (in US$) of Trinidad and Tobago?
Your response must be concise. -4.74e+08. In the year 2001, what is the difference between the Trade (in US$) in Caribbean small states and Trade (in US$) in Cambodia?
Provide a short and direct response. 1.25e+1. In the year 2001, what is the difference between the Trade (in US$) in Caribbean small states and Trade (in US$) in Cote d'Ivoire?
Keep it short and to the point. 1.01e+1. In the year 2001, what is the difference between the Trade (in US$) in Caribbean small states and Trade (in US$) in Trinidad and Tobago?
Your response must be concise. 9.73e+09. In the year 2001, what is the difference between the Trade (in US$) in Cambodia and Trade (in US$) in Cote d'Ivoire?
Provide a succinct answer. -2.46e+09. In the year 2001, what is the difference between the Trade (in US$) in Cambodia and Trade (in US$) in Trinidad and Tobago?
Offer a terse response. -2.81e+09. In the year 2001, what is the difference between the Trade (in US$) in Cote d'Ivoire and Trade (in US$) in Trinidad and Tobago?
Offer a very short reply. -3.52e+08. In the year 2002, what is the difference between the Trade (in US$) of Caribbean small states and Trade (in US$) of Cambodia?
Your answer should be very brief. 1.22e+1. In the year 2002, what is the difference between the Trade (in US$) in Caribbean small states and Trade (in US$) in Cote d'Ivoire?
Keep it short and to the point. 8.76e+09. In the year 2002, what is the difference between the Trade (in US$) of Caribbean small states and Trade (in US$) of Trinidad and Tobago?
Offer a very short reply. 1.01e+1. In the year 2002, what is the difference between the Trade (in US$) in Cambodia and Trade (in US$) in Cote d'Ivoire?
Your response must be concise. -3.49e+09. In the year 2002, what is the difference between the Trade (in US$) in Cambodia and Trade (in US$) in Trinidad and Tobago?
Your response must be concise. -2.18e+09. In the year 2002, what is the difference between the Trade (in US$) in Cote d'Ivoire and Trade (in US$) in Trinidad and Tobago?
Give a very brief answer. 1.30e+09. In the year 2003, what is the difference between the Trade (in US$) in Caribbean small states and Trade (in US$) in Cambodia?
Your answer should be compact. 1.39e+1. In the year 2003, what is the difference between the Trade (in US$) in Caribbean small states and Trade (in US$) in Cote d'Ivoire?
Offer a very short reply. 1.01e+1. In the year 2003, what is the difference between the Trade (in US$) of Caribbean small states and Trade (in US$) of Trinidad and Tobago?
Give a very brief answer. 1.07e+1. In the year 2003, what is the difference between the Trade (in US$) of Cambodia and Trade (in US$) of Cote d'Ivoire?
Your answer should be very brief. -3.78e+09. In the year 2003, what is the difference between the Trade (in US$) in Cambodia and Trade (in US$) in Trinidad and Tobago?
Offer a very short reply. -3.26e+09. In the year 2003, what is the difference between the Trade (in US$) of Cote d'Ivoire and Trade (in US$) of Trinidad and Tobago?
Offer a terse response. 5.21e+08. In the year 2004, what is the difference between the Trade (in US$) of Caribbean small states and Trade (in US$) of Cambodia?
Your response must be concise. 1.56e+1. In the year 2004, what is the difference between the Trade (in US$) in Caribbean small states and Trade (in US$) in Cote d'Ivoire?
Your answer should be compact. 1.14e+1. In the year 2004, what is the difference between the Trade (in US$) of Caribbean small states and Trade (in US$) of Trinidad and Tobago?
Give a very brief answer. 1.18e+1. In the year 2004, what is the difference between the Trade (in US$) in Cambodia and Trade (in US$) in Cote d'Ivoire?
Ensure brevity in your answer.  -4.29e+09. In the year 2004, what is the difference between the Trade (in US$) in Cambodia and Trade (in US$) in Trinidad and Tobago?
Ensure brevity in your answer.  -3.86e+09. In the year 2004, what is the difference between the Trade (in US$) in Cote d'Ivoire and Trade (in US$) in Trinidad and Tobago?
Keep it short and to the point. 4.28e+08. In the year 2005, what is the difference between the Trade (in US$) of Caribbean small states and Trade (in US$) of Cambodia?
Give a very brief answer. 1.93e+1. In the year 2005, what is the difference between the Trade (in US$) of Caribbean small states and Trade (in US$) of Cote d'Ivoire?
Offer a very short reply. 1.48e+1. In the year 2005, what is the difference between the Trade (in US$) of Caribbean small states and Trade (in US$) of Trinidad and Tobago?
Keep it short and to the point. 1.28e+1. In the year 2005, what is the difference between the Trade (in US$) in Cambodia and Trade (in US$) in Cote d'Ivoire?
Provide a short and direct response. -4.49e+09. In the year 2005, what is the difference between the Trade (in US$) of Cambodia and Trade (in US$) of Trinidad and Tobago?
Your answer should be very brief. -6.54e+09. In the year 2005, what is the difference between the Trade (in US$) in Cote d'Ivoire and Trade (in US$) in Trinidad and Tobago?
Your answer should be very brief. -2.04e+09. In the year 2006, what is the difference between the Trade (in US$) of Caribbean small states and Trade (in US$) of Cambodia?
Give a very brief answer. 2.42e+1. In the year 2006, what is the difference between the Trade (in US$) of Caribbean small states and Trade (in US$) of Cote d'Ivoire?
Make the answer very short. 1.99e+1. In the year 2006, what is the difference between the Trade (in US$) of Caribbean small states and Trade (in US$) of Trinidad and Tobago?
Your answer should be very brief. 1.42e+1. In the year 2006, what is the difference between the Trade (in US$) in Cambodia and Trade (in US$) in Cote d'Ivoire?
Make the answer very short. -4.33e+09. In the year 2006, what is the difference between the Trade (in US$) of Cambodia and Trade (in US$) of Trinidad and Tobago?
Ensure brevity in your answer.  -1.00e+1. In the year 2006, what is the difference between the Trade (in US$) in Cote d'Ivoire and Trade (in US$) in Trinidad and Tobago?
Keep it short and to the point. -5.71e+09. What is the ratio of the Trade (in US$) of Caribbean small states in 1999 to that in 2000?
Provide a short and direct response. 0.85. What is the ratio of the Trade (in US$) of Cambodia in 1999 to that in 2000?
Offer a very short reply. 0.78. What is the ratio of the Trade (in US$) of Cote d'Ivoire in 1999 to that in 2000?
Offer a terse response. 1.2. What is the ratio of the Trade (in US$) of Trinidad and Tobago in 1999 to that in 2000?
Your answer should be compact. 0.71. What is the ratio of the Trade (in US$) of Caribbean small states in 1999 to that in 2001?
Your answer should be very brief. 0.88. What is the ratio of the Trade (in US$) in Cambodia in 1999 to that in 2001?
Your answer should be compact. 0.68. What is the ratio of the Trade (in US$) in Cote d'Ivoire in 1999 to that in 2001?
Give a very brief answer. 1.15. What is the ratio of the Trade (in US$) in Trinidad and Tobago in 1999 to that in 2001?
Your answer should be compact. 0.7. What is the ratio of the Trade (in US$) of Caribbean small states in 1999 to that in 2002?
Offer a very short reply. 0.88. What is the ratio of the Trade (in US$) of Cambodia in 1999 to that in 2002?
Your answer should be compact. 0.6. What is the ratio of the Trade (in US$) in Cote d'Ivoire in 1999 to that in 2002?
Give a very brief answer. 0.9. What is the ratio of the Trade (in US$) of Trinidad and Tobago in 1999 to that in 2002?
Make the answer very short. 0.75. What is the ratio of the Trade (in US$) of Caribbean small states in 1999 to that in 2003?
Offer a terse response. 0.78. What is the ratio of the Trade (in US$) in Cambodia in 1999 to that in 2003?
Give a very brief answer. 0.54. What is the ratio of the Trade (in US$) of Cote d'Ivoire in 1999 to that in 2003?
Give a very brief answer. 0.82. What is the ratio of the Trade (in US$) in Trinidad and Tobago in 1999 to that in 2003?
Your answer should be very brief. 0.58. What is the ratio of the Trade (in US$) of Caribbean small states in 1999 to that in 2004?
Your answer should be compact. 0.68. What is the ratio of the Trade (in US$) of Cambodia in 1999 to that in 2004?
Keep it short and to the point. 0.42. What is the ratio of the Trade (in US$) of Cote d'Ivoire in 1999 to that in 2004?
Offer a very short reply. 0.68. What is the ratio of the Trade (in US$) of Trinidad and Tobago in 1999 to that in 2004?
Provide a short and direct response. 0.47. What is the ratio of the Trade (in US$) of Caribbean small states in 1999 to that in 2005?
Provide a succinct answer. 0.55. What is the ratio of the Trade (in US$) in Cambodia in 1999 to that in 2005?
Offer a terse response. 0.35. What is the ratio of the Trade (in US$) in Cote d'Ivoire in 1999 to that in 2005?
Make the answer very short. 0.62. What is the ratio of the Trade (in US$) in Trinidad and Tobago in 1999 to that in 2005?
Your answer should be compact. 0.32. What is the ratio of the Trade (in US$) in Caribbean small states in 1999 to that in 2006?
Your response must be concise. 0.44. What is the ratio of the Trade (in US$) of Cambodia in 1999 to that in 2006?
Give a very brief answer. 0.29. What is the ratio of the Trade (in US$) of Cote d'Ivoire in 1999 to that in 2006?
Your answer should be very brief. 0.56. What is the ratio of the Trade (in US$) in Trinidad and Tobago in 1999 to that in 2006?
Your answer should be very brief. 0.23. What is the ratio of the Trade (in US$) of Caribbean small states in 2000 to that in 2001?
Give a very brief answer. 1.03. What is the ratio of the Trade (in US$) of Cambodia in 2000 to that in 2001?
Ensure brevity in your answer.  0.87. What is the ratio of the Trade (in US$) in Cote d'Ivoire in 2000 to that in 2001?
Your response must be concise. 0.96. What is the ratio of the Trade (in US$) of Trinidad and Tobago in 2000 to that in 2001?
Offer a very short reply. 0.99. What is the ratio of the Trade (in US$) of Caribbean small states in 2000 to that in 2002?
Make the answer very short. 1.03. What is the ratio of the Trade (in US$) of Cambodia in 2000 to that in 2002?
Your answer should be compact. 0.77. What is the ratio of the Trade (in US$) of Cote d'Ivoire in 2000 to that in 2002?
Your answer should be compact. 0.75. What is the ratio of the Trade (in US$) in Trinidad and Tobago in 2000 to that in 2002?
Ensure brevity in your answer.  1.06. What is the ratio of the Trade (in US$) of Caribbean small states in 2000 to that in 2003?
Your answer should be compact. 0.91. What is the ratio of the Trade (in US$) of Cambodia in 2000 to that in 2003?
Offer a terse response. 0.69. What is the ratio of the Trade (in US$) of Cote d'Ivoire in 2000 to that in 2003?
Your answer should be compact. 0.68. What is the ratio of the Trade (in US$) of Trinidad and Tobago in 2000 to that in 2003?
Your answer should be compact. 0.82. What is the ratio of the Trade (in US$) in Caribbean small states in 2000 to that in 2004?
Offer a very short reply. 0.79. What is the ratio of the Trade (in US$) of Cambodia in 2000 to that in 2004?
Give a very brief answer. 0.54. What is the ratio of the Trade (in US$) in Cote d'Ivoire in 2000 to that in 2004?
Keep it short and to the point. 0.57. What is the ratio of the Trade (in US$) of Trinidad and Tobago in 2000 to that in 2004?
Offer a very short reply. 0.67. What is the ratio of the Trade (in US$) of Caribbean small states in 2000 to that in 2005?
Make the answer very short. 0.65. What is the ratio of the Trade (in US$) in Cambodia in 2000 to that in 2005?
Offer a terse response. 0.45. What is the ratio of the Trade (in US$) of Cote d'Ivoire in 2000 to that in 2005?
Make the answer very short. 0.51. What is the ratio of the Trade (in US$) of Trinidad and Tobago in 2000 to that in 2005?
Keep it short and to the point. 0.46. What is the ratio of the Trade (in US$) in Caribbean small states in 2000 to that in 2006?
Ensure brevity in your answer.  0.52. What is the ratio of the Trade (in US$) of Cambodia in 2000 to that in 2006?
Your answer should be very brief. 0.36. What is the ratio of the Trade (in US$) of Cote d'Ivoire in 2000 to that in 2006?
Keep it short and to the point. 0.47. What is the ratio of the Trade (in US$) in Trinidad and Tobago in 2000 to that in 2006?
Provide a short and direct response. 0.32. What is the ratio of the Trade (in US$) of Cambodia in 2001 to that in 2002?
Provide a succinct answer. 0.88. What is the ratio of the Trade (in US$) of Cote d'Ivoire in 2001 to that in 2002?
Offer a terse response. 0.78. What is the ratio of the Trade (in US$) of Trinidad and Tobago in 2001 to that in 2002?
Offer a very short reply. 1.08. What is the ratio of the Trade (in US$) of Caribbean small states in 2001 to that in 2003?
Provide a succinct answer. 0.88. What is the ratio of the Trade (in US$) of Cambodia in 2001 to that in 2003?
Offer a very short reply. 0.8. What is the ratio of the Trade (in US$) of Cote d'Ivoire in 2001 to that in 2003?
Offer a very short reply. 0.71. What is the ratio of the Trade (in US$) of Trinidad and Tobago in 2001 to that in 2003?
Keep it short and to the point. 0.83. What is the ratio of the Trade (in US$) in Caribbean small states in 2001 to that in 2004?
Your answer should be compact. 0.77. What is the ratio of the Trade (in US$) in Cambodia in 2001 to that in 2004?
Ensure brevity in your answer.  0.62. What is the ratio of the Trade (in US$) in Cote d'Ivoire in 2001 to that in 2004?
Provide a succinct answer. 0.59. What is the ratio of the Trade (in US$) in Trinidad and Tobago in 2001 to that in 2004?
Give a very brief answer. 0.68. What is the ratio of the Trade (in US$) in Caribbean small states in 2001 to that in 2005?
Provide a short and direct response. 0.63. What is the ratio of the Trade (in US$) of Cambodia in 2001 to that in 2005?
Offer a terse response. 0.52. What is the ratio of the Trade (in US$) in Cote d'Ivoire in 2001 to that in 2005?
Your answer should be compact. 0.53. What is the ratio of the Trade (in US$) of Trinidad and Tobago in 2001 to that in 2005?
Provide a succinct answer. 0.46. What is the ratio of the Trade (in US$) of Caribbean small states in 2001 to that in 2006?
Offer a terse response. 0.5. What is the ratio of the Trade (in US$) of Cambodia in 2001 to that in 2006?
Give a very brief answer. 0.42. What is the ratio of the Trade (in US$) of Cote d'Ivoire in 2001 to that in 2006?
Provide a succinct answer. 0.49. What is the ratio of the Trade (in US$) in Trinidad and Tobago in 2001 to that in 2006?
Provide a succinct answer. 0.33. What is the ratio of the Trade (in US$) in Caribbean small states in 2002 to that in 2003?
Provide a short and direct response. 0.88. What is the ratio of the Trade (in US$) in Cambodia in 2002 to that in 2003?
Offer a very short reply. 0.9. What is the ratio of the Trade (in US$) in Cote d'Ivoire in 2002 to that in 2003?
Provide a short and direct response. 0.91. What is the ratio of the Trade (in US$) of Trinidad and Tobago in 2002 to that in 2003?
Offer a terse response. 0.77. What is the ratio of the Trade (in US$) of Caribbean small states in 2002 to that in 2004?
Provide a short and direct response. 0.77. What is the ratio of the Trade (in US$) of Cambodia in 2002 to that in 2004?
Your answer should be very brief. 0.7. What is the ratio of the Trade (in US$) in Cote d'Ivoire in 2002 to that in 2004?
Provide a short and direct response. 0.76. What is the ratio of the Trade (in US$) in Trinidad and Tobago in 2002 to that in 2004?
Give a very brief answer. 0.63. What is the ratio of the Trade (in US$) in Caribbean small states in 2002 to that in 2005?
Your response must be concise. 0.63. What is the ratio of the Trade (in US$) in Cambodia in 2002 to that in 2005?
Ensure brevity in your answer.  0.59. What is the ratio of the Trade (in US$) in Cote d'Ivoire in 2002 to that in 2005?
Give a very brief answer. 0.69. What is the ratio of the Trade (in US$) in Trinidad and Tobago in 2002 to that in 2005?
Give a very brief answer. 0.43. What is the ratio of the Trade (in US$) of Caribbean small states in 2002 to that in 2006?
Provide a succinct answer. 0.5. What is the ratio of the Trade (in US$) in Cambodia in 2002 to that in 2006?
Give a very brief answer. 0.48. What is the ratio of the Trade (in US$) of Cote d'Ivoire in 2002 to that in 2006?
Give a very brief answer. 0.63. What is the ratio of the Trade (in US$) in Trinidad and Tobago in 2002 to that in 2006?
Your response must be concise. 0.3. What is the ratio of the Trade (in US$) in Caribbean small states in 2003 to that in 2004?
Provide a short and direct response. 0.87. What is the ratio of the Trade (in US$) of Cambodia in 2003 to that in 2004?
Make the answer very short. 0.78. What is the ratio of the Trade (in US$) of Cote d'Ivoire in 2003 to that in 2004?
Your answer should be very brief. 0.83. What is the ratio of the Trade (in US$) of Trinidad and Tobago in 2003 to that in 2004?
Provide a succinct answer. 0.81. What is the ratio of the Trade (in US$) in Caribbean small states in 2003 to that in 2005?
Provide a short and direct response. 0.71. What is the ratio of the Trade (in US$) in Cambodia in 2003 to that in 2005?
Your answer should be compact. 0.65. What is the ratio of the Trade (in US$) in Cote d'Ivoire in 2003 to that in 2005?
Give a very brief answer. 0.75. What is the ratio of the Trade (in US$) of Trinidad and Tobago in 2003 to that in 2005?
Your answer should be compact. 0.56. What is the ratio of the Trade (in US$) of Caribbean small states in 2003 to that in 2006?
Give a very brief answer. 0.57. What is the ratio of the Trade (in US$) in Cambodia in 2003 to that in 2006?
Your response must be concise. 0.53. What is the ratio of the Trade (in US$) of Cote d'Ivoire in 2003 to that in 2006?
Provide a succinct answer. 0.69. What is the ratio of the Trade (in US$) of Trinidad and Tobago in 2003 to that in 2006?
Keep it short and to the point. 0.39. What is the ratio of the Trade (in US$) of Caribbean small states in 2004 to that in 2005?
Give a very brief answer. 0.82. What is the ratio of the Trade (in US$) in Cambodia in 2004 to that in 2005?
Keep it short and to the point. 0.84. What is the ratio of the Trade (in US$) in Cote d'Ivoire in 2004 to that in 2005?
Make the answer very short. 0.9. What is the ratio of the Trade (in US$) of Trinidad and Tobago in 2004 to that in 2005?
Give a very brief answer. 0.69. What is the ratio of the Trade (in US$) of Caribbean small states in 2004 to that in 2006?
Offer a terse response. 0.65. What is the ratio of the Trade (in US$) in Cambodia in 2004 to that in 2006?
Give a very brief answer. 0.68. What is the ratio of the Trade (in US$) in Cote d'Ivoire in 2004 to that in 2006?
Offer a terse response. 0.82. What is the ratio of the Trade (in US$) of Trinidad and Tobago in 2004 to that in 2006?
Keep it short and to the point. 0.48. What is the ratio of the Trade (in US$) of Caribbean small states in 2005 to that in 2006?
Your response must be concise. 0.8. What is the ratio of the Trade (in US$) of Cambodia in 2005 to that in 2006?
Offer a terse response. 0.81. What is the ratio of the Trade (in US$) in Cote d'Ivoire in 2005 to that in 2006?
Make the answer very short. 0.91. What is the ratio of the Trade (in US$) of Trinidad and Tobago in 2005 to that in 2006?
Provide a succinct answer. 0.7. What is the difference between the highest and the second highest Trade (in US$) of Caribbean small states?
Offer a very short reply. 5.87e+09. What is the difference between the highest and the second highest Trade (in US$) of Cambodia?
Your answer should be very brief. 9.57e+08. What is the difference between the highest and the second highest Trade (in US$) in Cote d'Ivoire?
Offer a terse response. 7.97e+08. What is the difference between the highest and the second highest Trade (in US$) in Trinidad and Tobago?
Give a very brief answer. 4.46e+09. What is the difference between the highest and the lowest Trade (in US$) in Caribbean small states?
Ensure brevity in your answer.  1.63e+1. What is the difference between the highest and the lowest Trade (in US$) of Cambodia?
Make the answer very short. 3.56e+09. What is the difference between the highest and the lowest Trade (in US$) in Cote d'Ivoire?
Offer a very short reply. 4.95e+09. What is the difference between the highest and the lowest Trade (in US$) of Trinidad and Tobago?
Provide a short and direct response. 1.16e+1. 